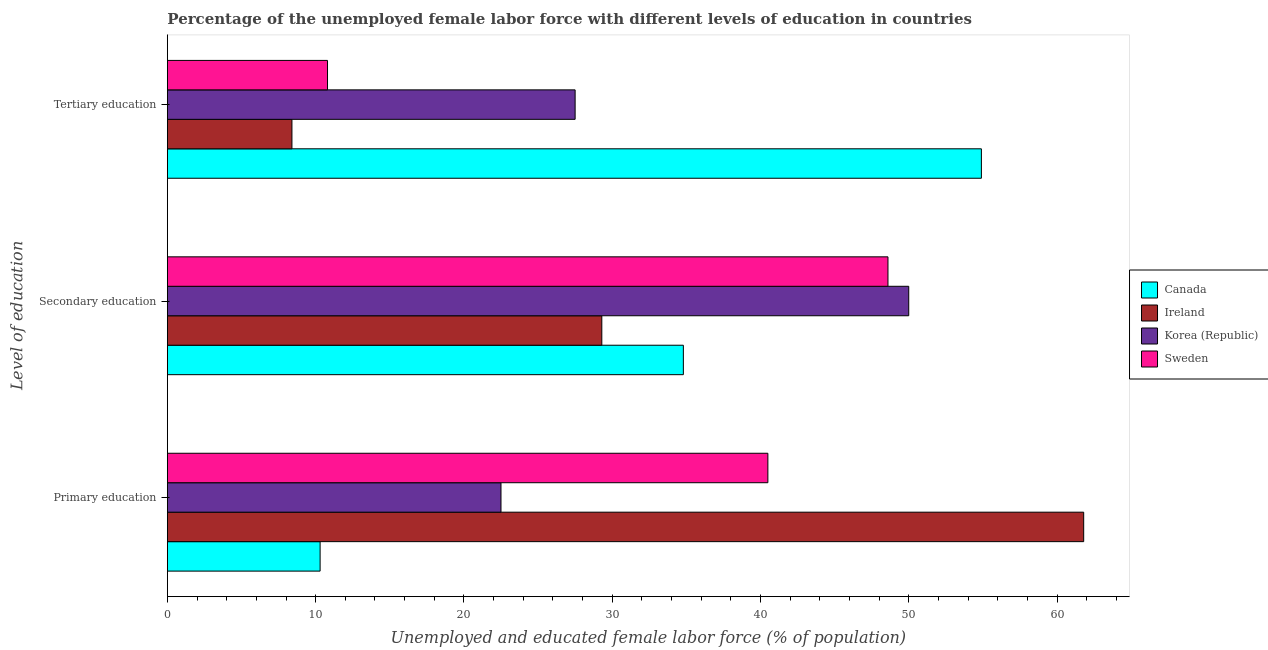How many different coloured bars are there?
Offer a very short reply. 4. How many groups of bars are there?
Your response must be concise. 3. How many bars are there on the 3rd tick from the top?
Ensure brevity in your answer.  4. What is the percentage of female labor force who received primary education in Sweden?
Keep it short and to the point. 40.5. Across all countries, what is the maximum percentage of female labor force who received tertiary education?
Give a very brief answer. 54.9. Across all countries, what is the minimum percentage of female labor force who received tertiary education?
Offer a very short reply. 8.4. In which country was the percentage of female labor force who received primary education maximum?
Your answer should be very brief. Ireland. What is the total percentage of female labor force who received tertiary education in the graph?
Offer a very short reply. 101.6. What is the difference between the percentage of female labor force who received secondary education in Canada and that in Korea (Republic)?
Provide a short and direct response. -15.2. What is the difference between the percentage of female labor force who received primary education in Korea (Republic) and the percentage of female labor force who received tertiary education in Sweden?
Give a very brief answer. 11.7. What is the average percentage of female labor force who received tertiary education per country?
Offer a terse response. 25.4. What is the difference between the percentage of female labor force who received secondary education and percentage of female labor force who received primary education in Canada?
Ensure brevity in your answer.  24.5. What is the ratio of the percentage of female labor force who received tertiary education in Sweden to that in Ireland?
Ensure brevity in your answer.  1.29. Is the percentage of female labor force who received primary education in Canada less than that in Sweden?
Offer a very short reply. Yes. What is the difference between the highest and the second highest percentage of female labor force who received secondary education?
Keep it short and to the point. 1.4. What is the difference between the highest and the lowest percentage of female labor force who received tertiary education?
Your answer should be compact. 46.5. Is the sum of the percentage of female labor force who received secondary education in Canada and Ireland greater than the maximum percentage of female labor force who received tertiary education across all countries?
Your answer should be very brief. Yes. Are all the bars in the graph horizontal?
Offer a very short reply. Yes. What is the difference between two consecutive major ticks on the X-axis?
Your answer should be compact. 10. Are the values on the major ticks of X-axis written in scientific E-notation?
Provide a succinct answer. No. Does the graph contain grids?
Provide a short and direct response. No. Where does the legend appear in the graph?
Offer a terse response. Center right. How are the legend labels stacked?
Keep it short and to the point. Vertical. What is the title of the graph?
Offer a terse response. Percentage of the unemployed female labor force with different levels of education in countries. Does "Venezuela" appear as one of the legend labels in the graph?
Offer a very short reply. No. What is the label or title of the X-axis?
Provide a succinct answer. Unemployed and educated female labor force (% of population). What is the label or title of the Y-axis?
Keep it short and to the point. Level of education. What is the Unemployed and educated female labor force (% of population) in Canada in Primary education?
Keep it short and to the point. 10.3. What is the Unemployed and educated female labor force (% of population) of Ireland in Primary education?
Offer a very short reply. 61.8. What is the Unemployed and educated female labor force (% of population) of Sweden in Primary education?
Keep it short and to the point. 40.5. What is the Unemployed and educated female labor force (% of population) in Canada in Secondary education?
Keep it short and to the point. 34.8. What is the Unemployed and educated female labor force (% of population) of Ireland in Secondary education?
Make the answer very short. 29.3. What is the Unemployed and educated female labor force (% of population) in Sweden in Secondary education?
Your answer should be compact. 48.6. What is the Unemployed and educated female labor force (% of population) of Canada in Tertiary education?
Your answer should be very brief. 54.9. What is the Unemployed and educated female labor force (% of population) in Ireland in Tertiary education?
Make the answer very short. 8.4. What is the Unemployed and educated female labor force (% of population) of Sweden in Tertiary education?
Keep it short and to the point. 10.8. Across all Level of education, what is the maximum Unemployed and educated female labor force (% of population) of Canada?
Offer a terse response. 54.9. Across all Level of education, what is the maximum Unemployed and educated female labor force (% of population) of Ireland?
Offer a very short reply. 61.8. Across all Level of education, what is the maximum Unemployed and educated female labor force (% of population) of Korea (Republic)?
Your answer should be very brief. 50. Across all Level of education, what is the maximum Unemployed and educated female labor force (% of population) of Sweden?
Offer a very short reply. 48.6. Across all Level of education, what is the minimum Unemployed and educated female labor force (% of population) in Canada?
Keep it short and to the point. 10.3. Across all Level of education, what is the minimum Unemployed and educated female labor force (% of population) of Ireland?
Your response must be concise. 8.4. Across all Level of education, what is the minimum Unemployed and educated female labor force (% of population) in Sweden?
Your response must be concise. 10.8. What is the total Unemployed and educated female labor force (% of population) of Ireland in the graph?
Offer a terse response. 99.5. What is the total Unemployed and educated female labor force (% of population) in Korea (Republic) in the graph?
Provide a succinct answer. 100. What is the total Unemployed and educated female labor force (% of population) of Sweden in the graph?
Provide a short and direct response. 99.9. What is the difference between the Unemployed and educated female labor force (% of population) of Canada in Primary education and that in Secondary education?
Keep it short and to the point. -24.5. What is the difference between the Unemployed and educated female labor force (% of population) of Ireland in Primary education and that in Secondary education?
Your answer should be compact. 32.5. What is the difference between the Unemployed and educated female labor force (% of population) in Korea (Republic) in Primary education and that in Secondary education?
Give a very brief answer. -27.5. What is the difference between the Unemployed and educated female labor force (% of population) in Sweden in Primary education and that in Secondary education?
Provide a short and direct response. -8.1. What is the difference between the Unemployed and educated female labor force (% of population) of Canada in Primary education and that in Tertiary education?
Offer a terse response. -44.6. What is the difference between the Unemployed and educated female labor force (% of population) in Ireland in Primary education and that in Tertiary education?
Provide a short and direct response. 53.4. What is the difference between the Unemployed and educated female labor force (% of population) in Sweden in Primary education and that in Tertiary education?
Your answer should be compact. 29.7. What is the difference between the Unemployed and educated female labor force (% of population) in Canada in Secondary education and that in Tertiary education?
Provide a succinct answer. -20.1. What is the difference between the Unemployed and educated female labor force (% of population) of Ireland in Secondary education and that in Tertiary education?
Your answer should be compact. 20.9. What is the difference between the Unemployed and educated female labor force (% of population) of Korea (Republic) in Secondary education and that in Tertiary education?
Offer a very short reply. 22.5. What is the difference between the Unemployed and educated female labor force (% of population) of Sweden in Secondary education and that in Tertiary education?
Ensure brevity in your answer.  37.8. What is the difference between the Unemployed and educated female labor force (% of population) in Canada in Primary education and the Unemployed and educated female labor force (% of population) in Korea (Republic) in Secondary education?
Ensure brevity in your answer.  -39.7. What is the difference between the Unemployed and educated female labor force (% of population) in Canada in Primary education and the Unemployed and educated female labor force (% of population) in Sweden in Secondary education?
Make the answer very short. -38.3. What is the difference between the Unemployed and educated female labor force (% of population) of Ireland in Primary education and the Unemployed and educated female labor force (% of population) of Korea (Republic) in Secondary education?
Keep it short and to the point. 11.8. What is the difference between the Unemployed and educated female labor force (% of population) of Ireland in Primary education and the Unemployed and educated female labor force (% of population) of Sweden in Secondary education?
Your answer should be very brief. 13.2. What is the difference between the Unemployed and educated female labor force (% of population) in Korea (Republic) in Primary education and the Unemployed and educated female labor force (% of population) in Sweden in Secondary education?
Offer a terse response. -26.1. What is the difference between the Unemployed and educated female labor force (% of population) in Canada in Primary education and the Unemployed and educated female labor force (% of population) in Korea (Republic) in Tertiary education?
Provide a short and direct response. -17.2. What is the difference between the Unemployed and educated female labor force (% of population) in Canada in Primary education and the Unemployed and educated female labor force (% of population) in Sweden in Tertiary education?
Your response must be concise. -0.5. What is the difference between the Unemployed and educated female labor force (% of population) in Ireland in Primary education and the Unemployed and educated female labor force (% of population) in Korea (Republic) in Tertiary education?
Your answer should be very brief. 34.3. What is the difference between the Unemployed and educated female labor force (% of population) of Ireland in Primary education and the Unemployed and educated female labor force (% of population) of Sweden in Tertiary education?
Offer a very short reply. 51. What is the difference between the Unemployed and educated female labor force (% of population) in Korea (Republic) in Primary education and the Unemployed and educated female labor force (% of population) in Sweden in Tertiary education?
Provide a short and direct response. 11.7. What is the difference between the Unemployed and educated female labor force (% of population) in Canada in Secondary education and the Unemployed and educated female labor force (% of population) in Ireland in Tertiary education?
Your answer should be very brief. 26.4. What is the difference between the Unemployed and educated female labor force (% of population) in Canada in Secondary education and the Unemployed and educated female labor force (% of population) in Sweden in Tertiary education?
Provide a short and direct response. 24. What is the difference between the Unemployed and educated female labor force (% of population) of Ireland in Secondary education and the Unemployed and educated female labor force (% of population) of Korea (Republic) in Tertiary education?
Provide a succinct answer. 1.8. What is the difference between the Unemployed and educated female labor force (% of population) in Korea (Republic) in Secondary education and the Unemployed and educated female labor force (% of population) in Sweden in Tertiary education?
Your response must be concise. 39.2. What is the average Unemployed and educated female labor force (% of population) of Canada per Level of education?
Keep it short and to the point. 33.33. What is the average Unemployed and educated female labor force (% of population) in Ireland per Level of education?
Give a very brief answer. 33.17. What is the average Unemployed and educated female labor force (% of population) in Korea (Republic) per Level of education?
Keep it short and to the point. 33.33. What is the average Unemployed and educated female labor force (% of population) in Sweden per Level of education?
Your answer should be very brief. 33.3. What is the difference between the Unemployed and educated female labor force (% of population) in Canada and Unemployed and educated female labor force (% of population) in Ireland in Primary education?
Provide a short and direct response. -51.5. What is the difference between the Unemployed and educated female labor force (% of population) in Canada and Unemployed and educated female labor force (% of population) in Korea (Republic) in Primary education?
Offer a terse response. -12.2. What is the difference between the Unemployed and educated female labor force (% of population) in Canada and Unemployed and educated female labor force (% of population) in Sweden in Primary education?
Your answer should be very brief. -30.2. What is the difference between the Unemployed and educated female labor force (% of population) in Ireland and Unemployed and educated female labor force (% of population) in Korea (Republic) in Primary education?
Your answer should be very brief. 39.3. What is the difference between the Unemployed and educated female labor force (% of population) of Ireland and Unemployed and educated female labor force (% of population) of Sweden in Primary education?
Offer a terse response. 21.3. What is the difference between the Unemployed and educated female labor force (% of population) in Korea (Republic) and Unemployed and educated female labor force (% of population) in Sweden in Primary education?
Keep it short and to the point. -18. What is the difference between the Unemployed and educated female labor force (% of population) in Canada and Unemployed and educated female labor force (% of population) in Korea (Republic) in Secondary education?
Offer a very short reply. -15.2. What is the difference between the Unemployed and educated female labor force (% of population) of Ireland and Unemployed and educated female labor force (% of population) of Korea (Republic) in Secondary education?
Ensure brevity in your answer.  -20.7. What is the difference between the Unemployed and educated female labor force (% of population) of Ireland and Unemployed and educated female labor force (% of population) of Sweden in Secondary education?
Make the answer very short. -19.3. What is the difference between the Unemployed and educated female labor force (% of population) in Canada and Unemployed and educated female labor force (% of population) in Ireland in Tertiary education?
Make the answer very short. 46.5. What is the difference between the Unemployed and educated female labor force (% of population) of Canada and Unemployed and educated female labor force (% of population) of Korea (Republic) in Tertiary education?
Your answer should be very brief. 27.4. What is the difference between the Unemployed and educated female labor force (% of population) in Canada and Unemployed and educated female labor force (% of population) in Sweden in Tertiary education?
Keep it short and to the point. 44.1. What is the difference between the Unemployed and educated female labor force (% of population) in Ireland and Unemployed and educated female labor force (% of population) in Korea (Republic) in Tertiary education?
Your answer should be compact. -19.1. What is the difference between the Unemployed and educated female labor force (% of population) of Ireland and Unemployed and educated female labor force (% of population) of Sweden in Tertiary education?
Give a very brief answer. -2.4. What is the ratio of the Unemployed and educated female labor force (% of population) of Canada in Primary education to that in Secondary education?
Your answer should be compact. 0.3. What is the ratio of the Unemployed and educated female labor force (% of population) of Ireland in Primary education to that in Secondary education?
Make the answer very short. 2.11. What is the ratio of the Unemployed and educated female labor force (% of population) in Korea (Republic) in Primary education to that in Secondary education?
Your answer should be compact. 0.45. What is the ratio of the Unemployed and educated female labor force (% of population) in Canada in Primary education to that in Tertiary education?
Make the answer very short. 0.19. What is the ratio of the Unemployed and educated female labor force (% of population) of Ireland in Primary education to that in Tertiary education?
Give a very brief answer. 7.36. What is the ratio of the Unemployed and educated female labor force (% of population) in Korea (Republic) in Primary education to that in Tertiary education?
Provide a succinct answer. 0.82. What is the ratio of the Unemployed and educated female labor force (% of population) of Sweden in Primary education to that in Tertiary education?
Make the answer very short. 3.75. What is the ratio of the Unemployed and educated female labor force (% of population) in Canada in Secondary education to that in Tertiary education?
Give a very brief answer. 0.63. What is the ratio of the Unemployed and educated female labor force (% of population) of Ireland in Secondary education to that in Tertiary education?
Keep it short and to the point. 3.49. What is the ratio of the Unemployed and educated female labor force (% of population) of Korea (Republic) in Secondary education to that in Tertiary education?
Your answer should be compact. 1.82. What is the ratio of the Unemployed and educated female labor force (% of population) in Sweden in Secondary education to that in Tertiary education?
Offer a terse response. 4.5. What is the difference between the highest and the second highest Unemployed and educated female labor force (% of population) in Canada?
Make the answer very short. 20.1. What is the difference between the highest and the second highest Unemployed and educated female labor force (% of population) of Ireland?
Give a very brief answer. 32.5. What is the difference between the highest and the second highest Unemployed and educated female labor force (% of population) of Korea (Republic)?
Provide a short and direct response. 22.5. What is the difference between the highest and the second highest Unemployed and educated female labor force (% of population) of Sweden?
Give a very brief answer. 8.1. What is the difference between the highest and the lowest Unemployed and educated female labor force (% of population) of Canada?
Offer a very short reply. 44.6. What is the difference between the highest and the lowest Unemployed and educated female labor force (% of population) in Ireland?
Keep it short and to the point. 53.4. What is the difference between the highest and the lowest Unemployed and educated female labor force (% of population) in Sweden?
Ensure brevity in your answer.  37.8. 